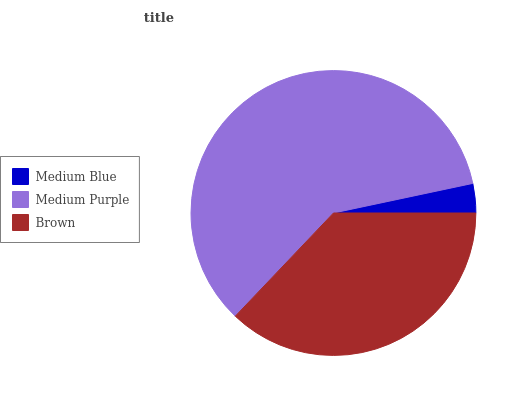Is Medium Blue the minimum?
Answer yes or no. Yes. Is Medium Purple the maximum?
Answer yes or no. Yes. Is Brown the minimum?
Answer yes or no. No. Is Brown the maximum?
Answer yes or no. No. Is Medium Purple greater than Brown?
Answer yes or no. Yes. Is Brown less than Medium Purple?
Answer yes or no. Yes. Is Brown greater than Medium Purple?
Answer yes or no. No. Is Medium Purple less than Brown?
Answer yes or no. No. Is Brown the high median?
Answer yes or no. Yes. Is Brown the low median?
Answer yes or no. Yes. Is Medium Blue the high median?
Answer yes or no. No. Is Medium Blue the low median?
Answer yes or no. No. 